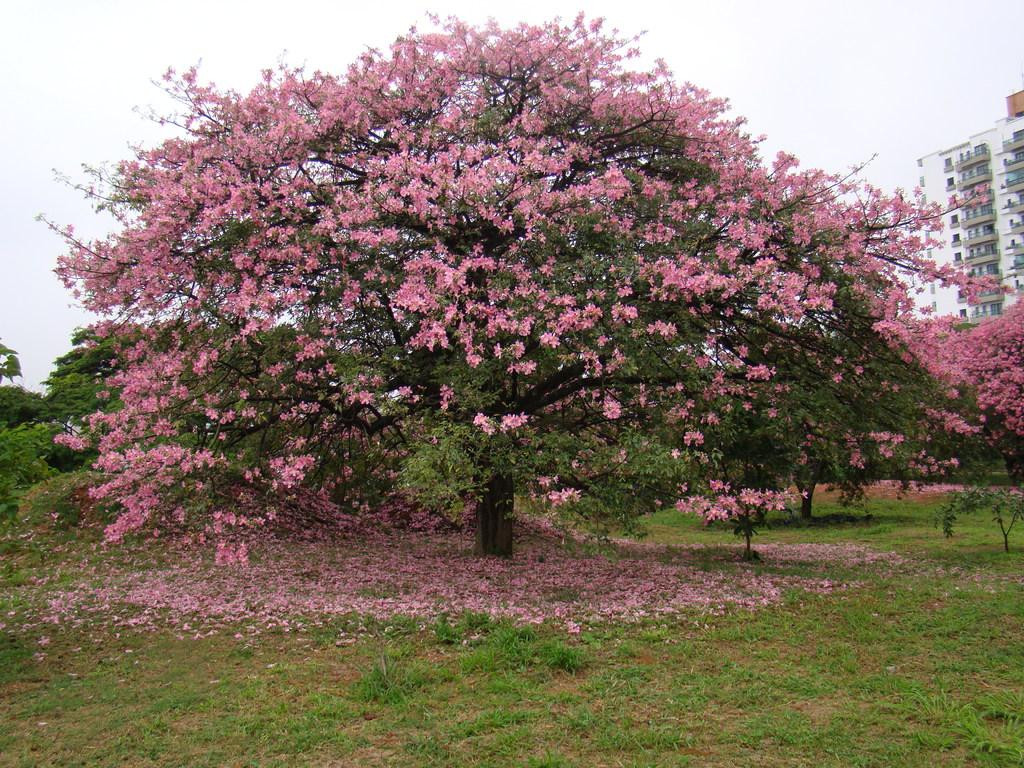What color are the flowers in the image? The flowers in the image are pink. What can be seen in the background of the image? There are trees in green color in the background of the image. What color are the buildings in the image? The buildings in the image are white. What color is the sky in the image? The sky is white in the image. Can you tell me which actor is standing behind the trees in the image? There are no actors present in the image; it features flowers, trees, buildings, and a white sky. 